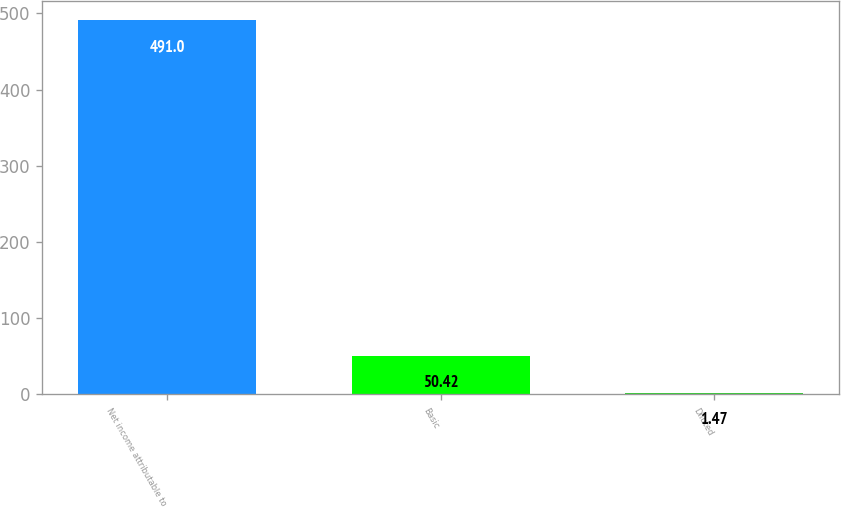Convert chart to OTSL. <chart><loc_0><loc_0><loc_500><loc_500><bar_chart><fcel>Net income attributable to<fcel>Basic<fcel>Diluted<nl><fcel>491<fcel>50.42<fcel>1.47<nl></chart> 